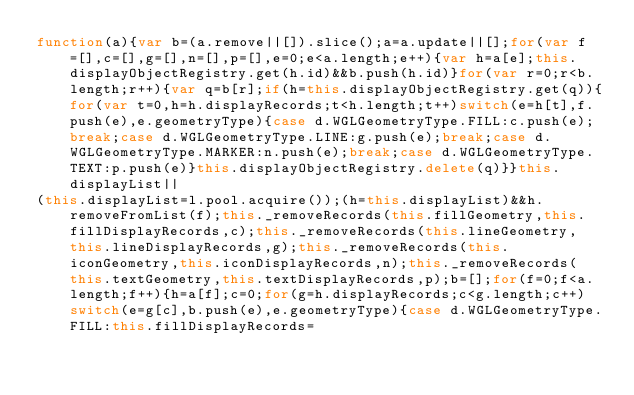Convert code to text. <code><loc_0><loc_0><loc_500><loc_500><_JavaScript_>function(a){var b=(a.remove||[]).slice();a=a.update||[];for(var f=[],c=[],g=[],n=[],p=[],e=0;e<a.length;e++){var h=a[e];this.displayObjectRegistry.get(h.id)&&b.push(h.id)}for(var r=0;r<b.length;r++){var q=b[r];if(h=this.displayObjectRegistry.get(q)){for(var t=0,h=h.displayRecords;t<h.length;t++)switch(e=h[t],f.push(e),e.geometryType){case d.WGLGeometryType.FILL:c.push(e);break;case d.WGLGeometryType.LINE:g.push(e);break;case d.WGLGeometryType.MARKER:n.push(e);break;case d.WGLGeometryType.TEXT:p.push(e)}this.displayObjectRegistry.delete(q)}}this.displayList||
(this.displayList=l.pool.acquire());(h=this.displayList)&&h.removeFromList(f);this._removeRecords(this.fillGeometry,this.fillDisplayRecords,c);this._removeRecords(this.lineGeometry,this.lineDisplayRecords,g);this._removeRecords(this.iconGeometry,this.iconDisplayRecords,n);this._removeRecords(this.textGeometry,this.textDisplayRecords,p);b=[];for(f=0;f<a.length;f++){h=a[f];c=0;for(g=h.displayRecords;c<g.length;c++)switch(e=g[c],b.push(e),e.geometryType){case d.WGLGeometryType.FILL:this.fillDisplayRecords=</code> 